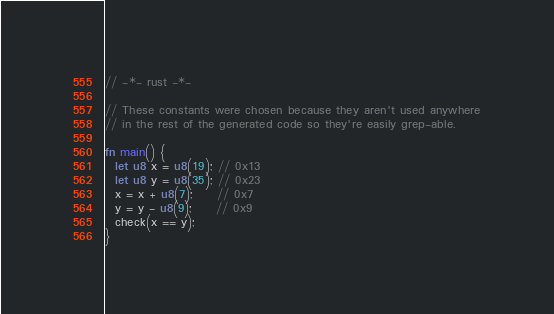Convert code to text. <code><loc_0><loc_0><loc_500><loc_500><_Rust_>// -*- rust -*-

// These constants were chosen because they aren't used anywhere
// in the rest of the generated code so they're easily grep-able.

fn main() {
  let u8 x = u8(19); // 0x13
  let u8 y = u8(35); // 0x23
  x = x + u8(7);     // 0x7
  y = y - u8(9);     // 0x9
  check(x == y);
}
</code> 